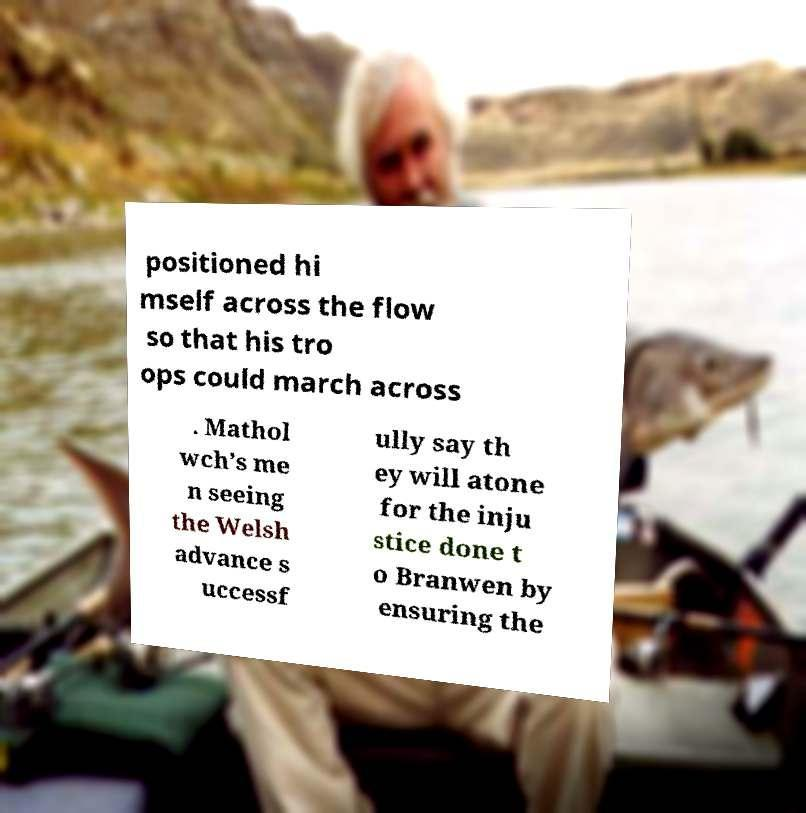What messages or text are displayed in this image? I need them in a readable, typed format. positioned hi mself across the flow so that his tro ops could march across . Mathol wch’s me n seeing the Welsh advance s uccessf ully say th ey will atone for the inju stice done t o Branwen by ensuring the 